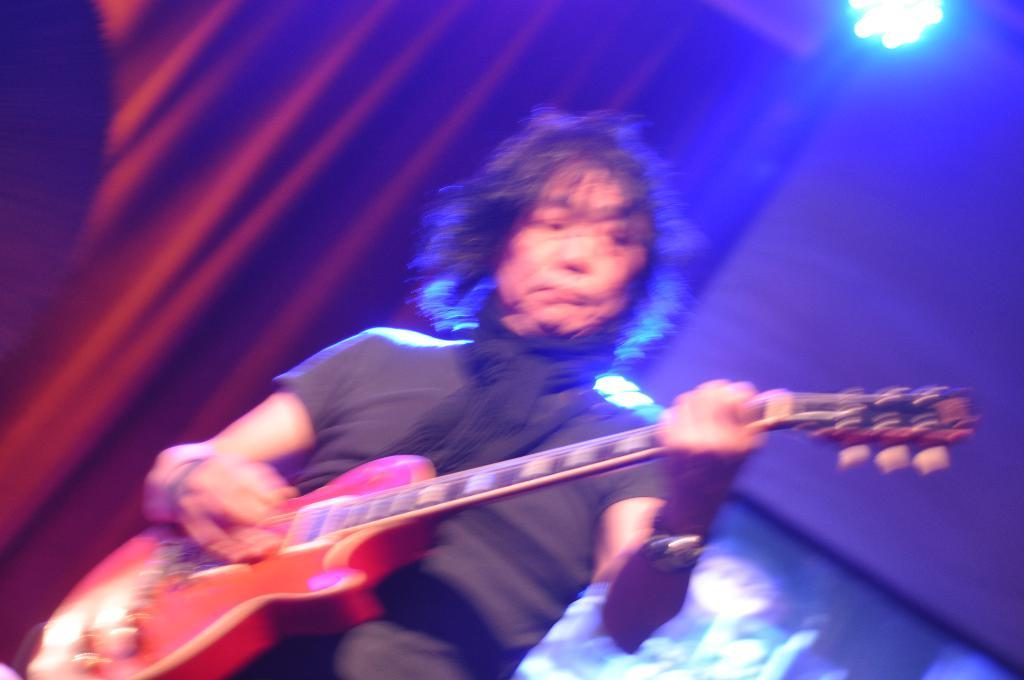What is the man in the image doing? The man is playing a guitar in the image. What is the man wearing in the image? The man is wearing a scarf in the image. What can be seen in the background of the image? There is a light and a red curtain in the image. How does the man grip the drain while playing the guitar in the image? There is no drain present in the image, so the man is not gripping a drain while playing the guitar. 